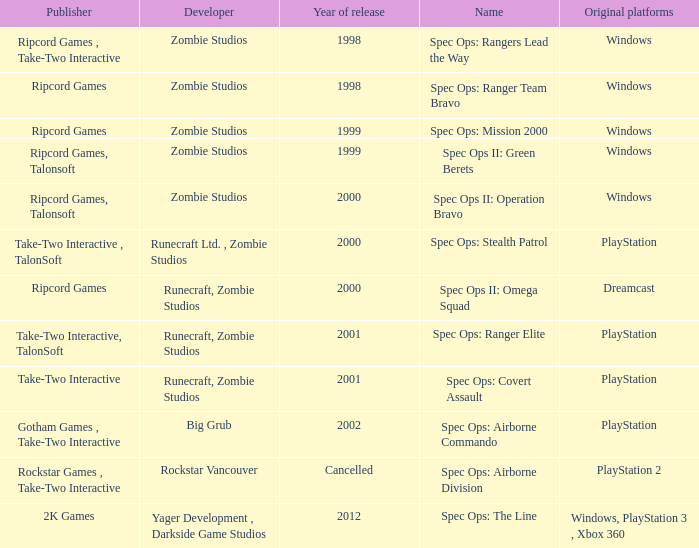Which developer has a year of cancelled releases? Rockstar Vancouver. 